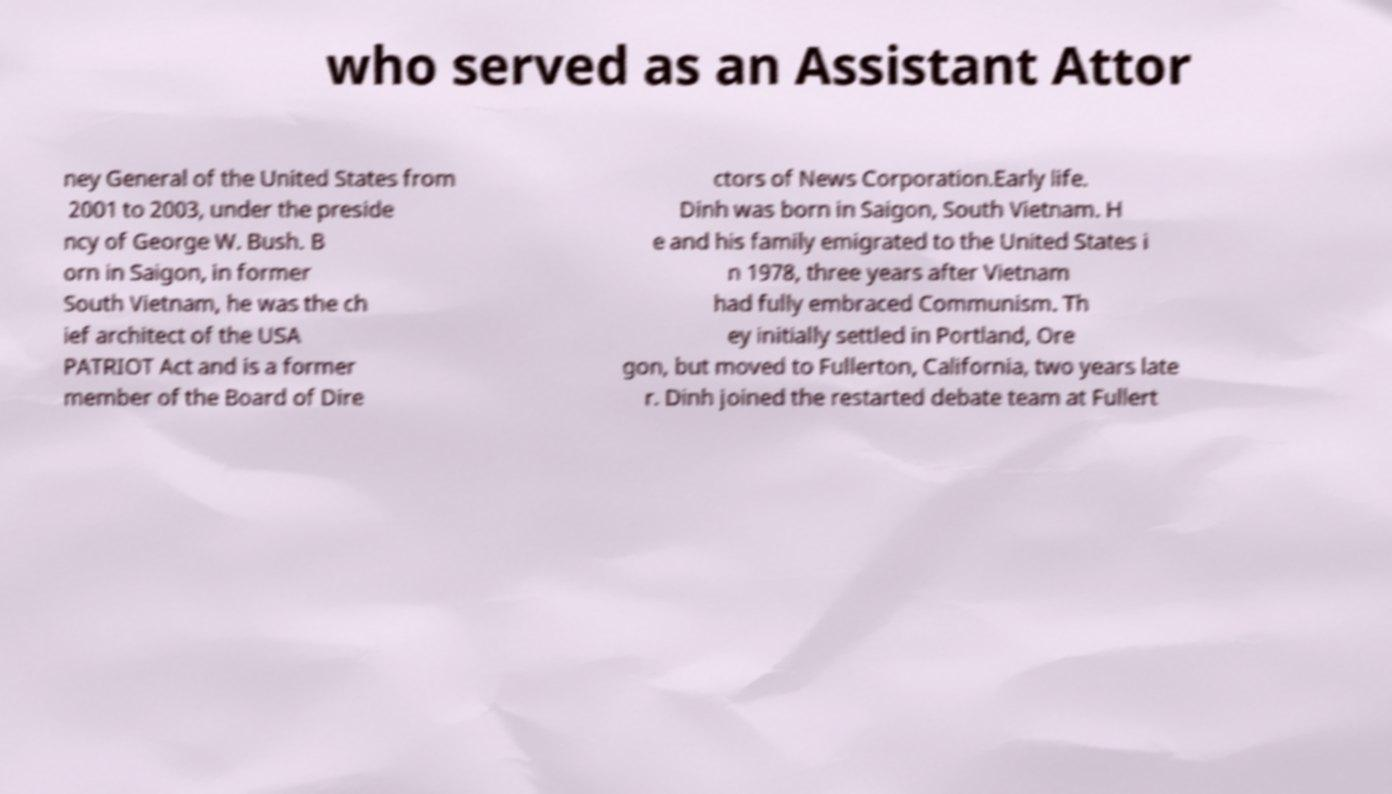Please read and relay the text visible in this image. What does it say? who served as an Assistant Attor ney General of the United States from 2001 to 2003, under the preside ncy of George W. Bush. B orn in Saigon, in former South Vietnam, he was the ch ief architect of the USA PATRIOT Act and is a former member of the Board of Dire ctors of News Corporation.Early life. Dinh was born in Saigon, South Vietnam. H e and his family emigrated to the United States i n 1978, three years after Vietnam had fully embraced Communism. Th ey initially settled in Portland, Ore gon, but moved to Fullerton, California, two years late r. Dinh joined the restarted debate team at Fullert 